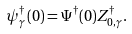Convert formula to latex. <formula><loc_0><loc_0><loc_500><loc_500>\psi _ { \gamma } ^ { \dagger } ( 0 ) = \Psi ^ { \dagger } ( 0 ) Z ^ { \dagger } _ { 0 , \gamma } .</formula> 